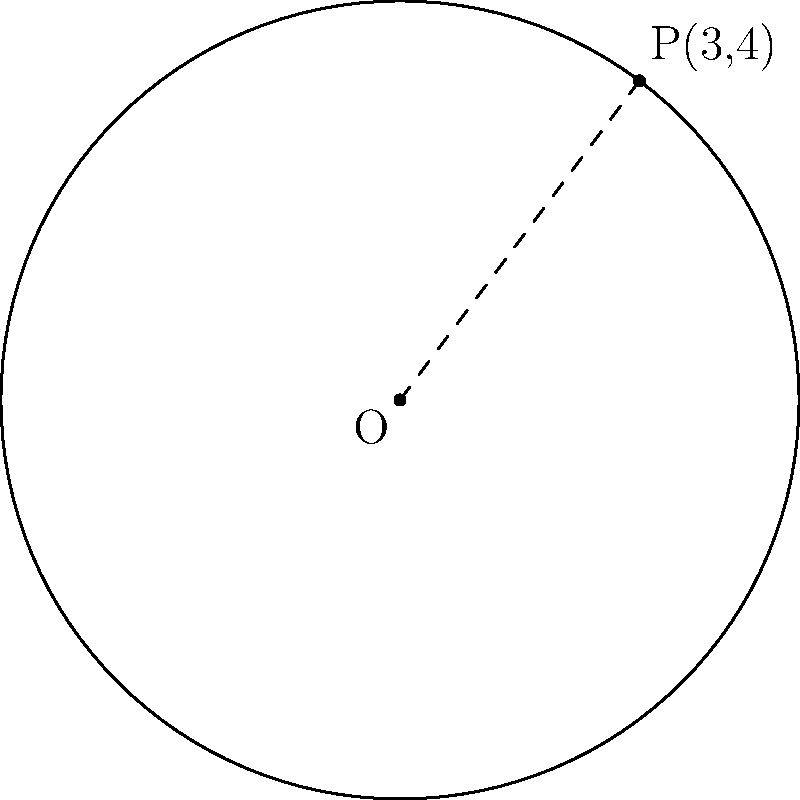As part of a new security initiative, you are planning to install a circular perimeter fence around a high-risk area. The center of the circular area is at the origin (0,0), and a point on the circumference is at (3,4). What is the equation of this circular fence? To find the equation of the circular fence, we can use the general equation of a circle:

$$(x-h)^2 + (y-k)^2 = r^2$$

Where (h,k) is the center of the circle and r is the radius.

Given:
1. The center is at the origin (0,0), so h = 0 and k = 0.
2. A point on the circumference is (3,4).

Steps:
1. Simplify the general equation since the center is at (0,0):
   $$x^2 + y^2 = r^2$$

2. Calculate the radius using the distance formula between (0,0) and (3,4):
   $$r^2 = 3^2 + 4^2 = 9 + 16 = 25$$
   $$r = 5$$

3. Substitute r^2 = 25 into the equation:
   $$x^2 + y^2 = 25$$

This is the equation of the circular fence.
Answer: $x^2 + y^2 = 25$ 